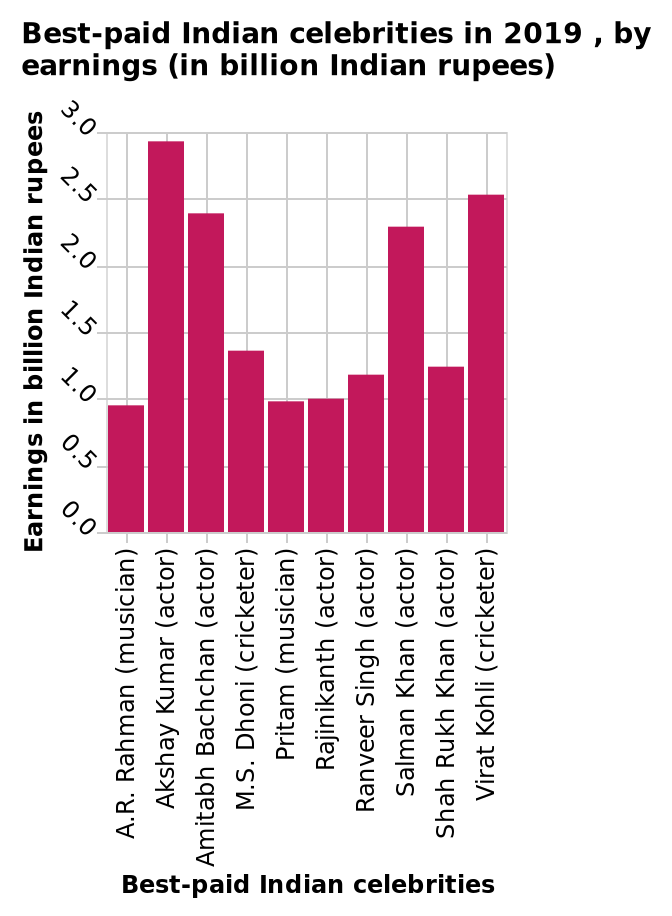<image>
Offer a thorough analysis of the image. There is a large variation in the earning of these celebrities with the highest at almost 3 billion rupees to the lowest at just under 1 billion. The lowest paid is a musician and the highest paid an actor. Who is the highest-paid Indian celebrity in 2019 according to the bar diagram? The highest-paid Indian celebrity in 2019, according to the bar diagram, is Virat Kohli, who is a cricketer. How many Indian celebrities are represented in the bar diagram? There are a total of several Indian celebrities represented in the bar diagram. The exact number is not mentioned in the given description. 